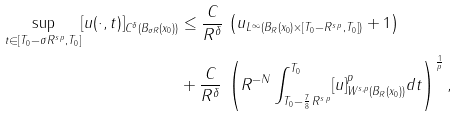Convert formula to latex. <formula><loc_0><loc_0><loc_500><loc_500>\sup _ { t \in [ T _ { 0 } - \sigma R ^ { s \, p } , T _ { 0 } ] } [ u ( \cdot , t ) ] _ { C ^ { \delta } ( B _ { \sigma R } ( x _ { 0 } ) ) } & \leq \frac { C } { R ^ { \delta } } \, \left ( \| u \| _ { L ^ { \infty } ( B _ { R } ( x _ { 0 } ) \times [ T _ { 0 } - R ^ { s \, p } , T _ { 0 } ] ) } + 1 \right ) \\ & + \frac { C } { R ^ { \delta } } \, \left ( R ^ { - N } \int _ { T _ { 0 } - \frac { 7 } { 8 } \, R ^ { s \, p } } ^ { T _ { 0 } } [ u ] _ { W ^ { s , p } ( B _ { R } ( x _ { 0 } ) ) } ^ { p } d t \right ) ^ { \frac { 1 } { p } } ,</formula> 